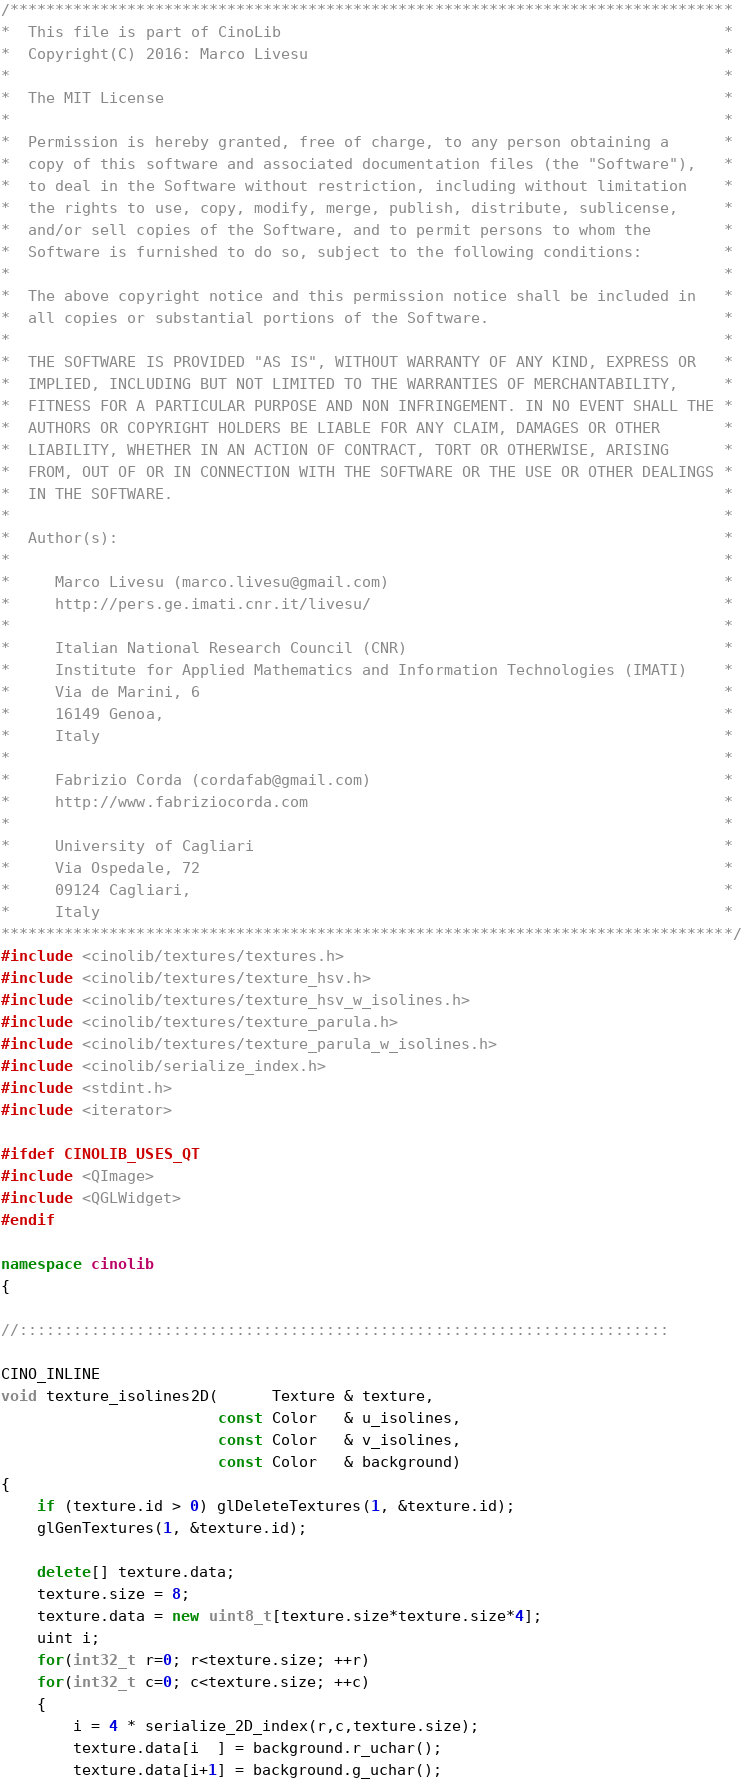Convert code to text. <code><loc_0><loc_0><loc_500><loc_500><_C++_>/********************************************************************************
*  This file is part of CinoLib                                                 *
*  Copyright(C) 2016: Marco Livesu                                              *
*                                                                               *
*  The MIT License                                                              *
*                                                                               *
*  Permission is hereby granted, free of charge, to any person obtaining a      *
*  copy of this software and associated documentation files (the "Software"),   *
*  to deal in the Software without restriction, including without limitation    *
*  the rights to use, copy, modify, merge, publish, distribute, sublicense,     *
*  and/or sell copies of the Software, and to permit persons to whom the        *
*  Software is furnished to do so, subject to the following conditions:         *
*                                                                               *
*  The above copyright notice and this permission notice shall be included in   *
*  all copies or substantial portions of the Software.                          *
*                                                                               *
*  THE SOFTWARE IS PROVIDED "AS IS", WITHOUT WARRANTY OF ANY KIND, EXPRESS OR   *
*  IMPLIED, INCLUDING BUT NOT LIMITED TO THE WARRANTIES OF MERCHANTABILITY,     *
*  FITNESS FOR A PARTICULAR PURPOSE AND NON INFRINGEMENT. IN NO EVENT SHALL THE *
*  AUTHORS OR COPYRIGHT HOLDERS BE LIABLE FOR ANY CLAIM, DAMAGES OR OTHER       *
*  LIABILITY, WHETHER IN AN ACTION OF CONTRACT, TORT OR OTHERWISE, ARISING      *
*  FROM, OUT OF OR IN CONNECTION WITH THE SOFTWARE OR THE USE OR OTHER DEALINGS *
*  IN THE SOFTWARE.                                                             *
*                                                                               *
*  Author(s):                                                                   *
*                                                                               *
*     Marco Livesu (marco.livesu@gmail.com)                                     *
*     http://pers.ge.imati.cnr.it/livesu/                                       *
*                                                                               *
*     Italian National Research Council (CNR)                                   *
*     Institute for Applied Mathematics and Information Technologies (IMATI)    *
*     Via de Marini, 6                                                          *
*     16149 Genoa,                                                              *
*     Italy                                                                     *
*                                                                               *
*     Fabrizio Corda (cordafab@gmail.com)                                       *
*     http://www.fabriziocorda.com                                              *
*                                                                               *
*     University of Cagliari                                                    *
*     Via Ospedale, 72                                                          *
*     09124 Cagliari,                                                           *
*     Italy                                                                     *
*********************************************************************************/
#include <cinolib/textures/textures.h>
#include <cinolib/textures/texture_hsv.h>
#include <cinolib/textures/texture_hsv_w_isolines.h>
#include <cinolib/textures/texture_parula.h>
#include <cinolib/textures/texture_parula_w_isolines.h>
#include <cinolib/serialize_index.h>
#include <stdint.h>
#include <iterator>

#ifdef CINOLIB_USES_QT
#include <QImage>
#include <QGLWidget>
#endif

namespace cinolib
{

//::::::::::::::::::::::::::::::::::::::::::::::::::::::::::::::::::::::::

CINO_INLINE
void texture_isolines2D(      Texture & texture,
                        const Color   & u_isolines,
                        const Color   & v_isolines,
                        const Color   & background)
{
    if (texture.id > 0) glDeleteTextures(1, &texture.id);
    glGenTextures(1, &texture.id);

    delete[] texture.data;
    texture.size = 8;
    texture.data = new uint8_t[texture.size*texture.size*4];
    uint i;
    for(int32_t r=0; r<texture.size; ++r)
    for(int32_t c=0; c<texture.size; ++c)
    {
        i = 4 * serialize_2D_index(r,c,texture.size);
        texture.data[i  ] = background.r_uchar();
        texture.data[i+1] = background.g_uchar();</code> 